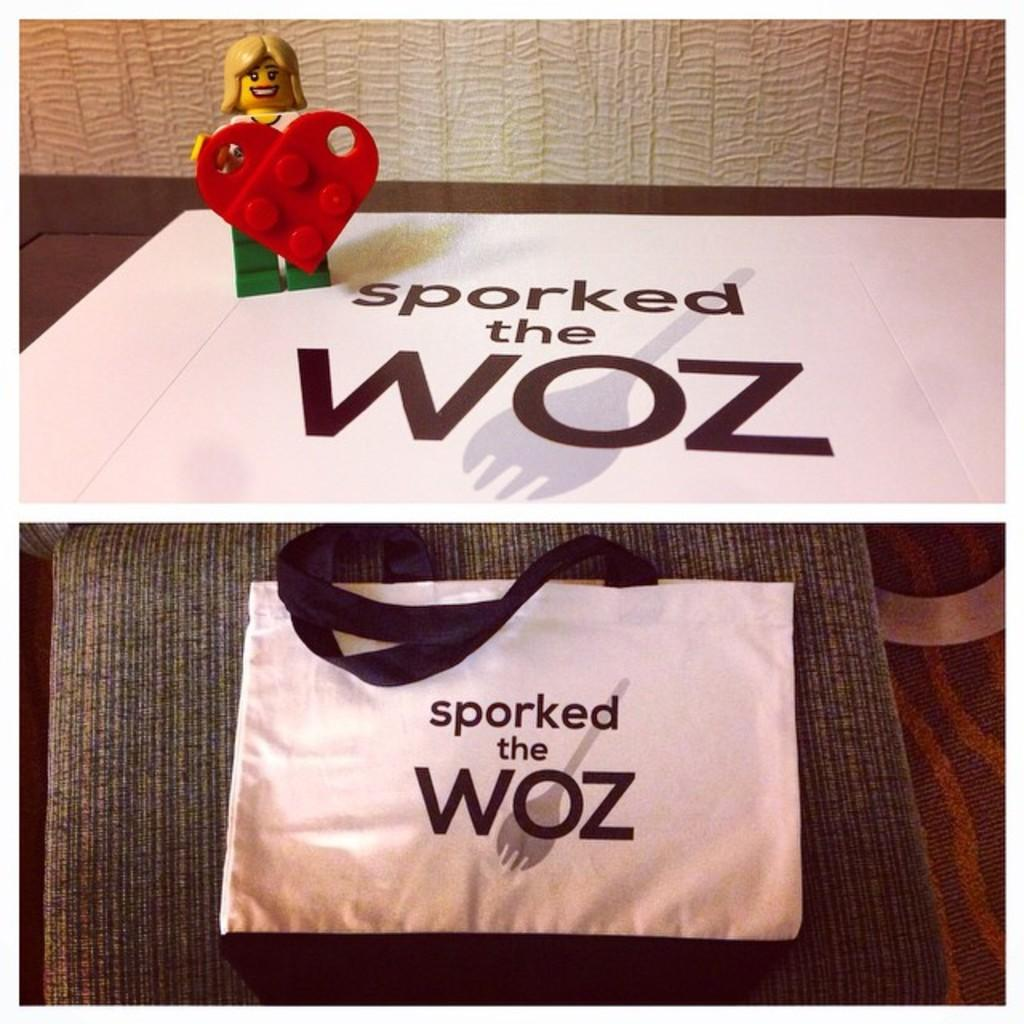What is one of the objects in the image? There is a bag in the image. What is another object in the image? There is a toy in the image. What color is the surface on which the objects are placed? The objects are on a white color surface. Are there any writings or labels on any of the objects? Yes, there is writing on white color objects. How is the image composed? The image is a collage. What caused the dad to be present at the birth of the child in the image? There is no mention of a dad or a birth in the image; it only features a bag, a toy, and writing on white color objects. 